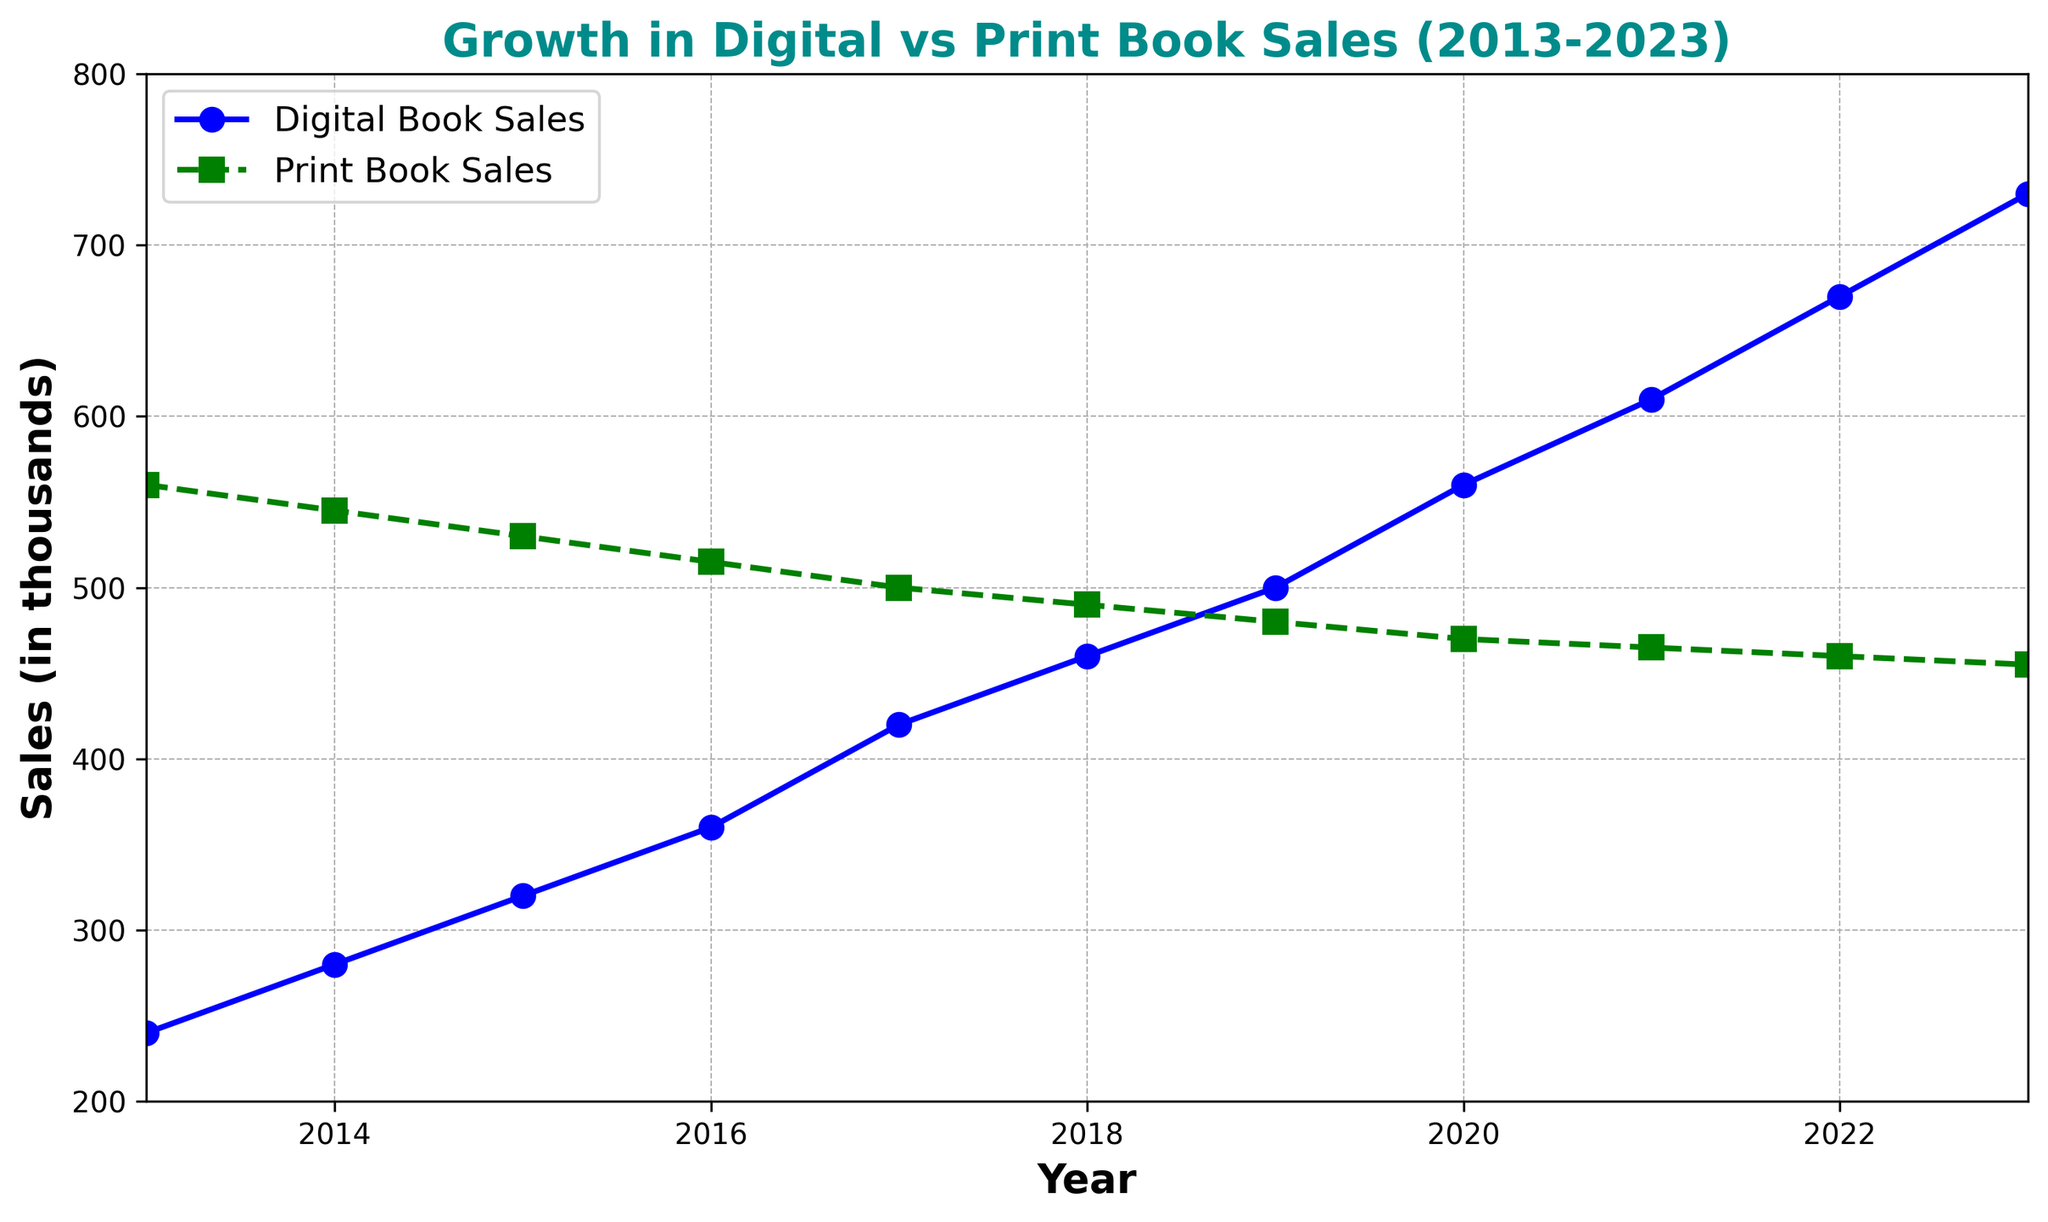Which year had the highest digital book sales? As we can see in the plot, 2023 had the highest point for digital book sales. This indicates that it had the highest digital book sales among all the years shown in the plot.
Answer: 2023 In what year did print book sales first drop below 500,000? By looking at the green dashed line representing print book sales, we see that it first dropped below 500,000 in 2018. Years 2017 and earlier are above 500,000.
Answer: 2018 How much has digital book sales increased from 2013 to 2023? The digital book sales in 2013 were 240,000, and in 2023, they were 730,000. Subtracting the former from the latter gives us the total increase: 730,000 - 240,000.
Answer: 490,000 Which year shows the largest gap between digital and print book sales? We need to compare the differences between blue and green lines for each year. The largest gap appears in 2023, where digital book sales are significantly higher than print book sales.
Answer: 2023 During which years did digital book sales exceed print book sales? From the plot, digital book sales exceed print book sales during 2020, 2021, 2022, and 2023.
Answer: 2020, 2021, 2022, 2023 What is the average print book sales from 2013 to 2023? The print book sales values from 2013 to 2023 are: 560, 545, 530, 515, 500, 490, 480, 470, 465, 460, 455. Summing these and dividing by 11 gives us the average: (560 + 545 + 530 + 515 + 500 + 490 + 480 + 470 + 465 + 460 + 455) / 11.
Answer: 495,000 What was the trend in digital book sales between 2015 and 2020? The blue line for digital book sales shows a steady rise from 2015 (320,000) to 2020 (560,000), indicating a consistent growth trend.
Answer: Steady rise Which type of book sales showed a consistent decline over the years? The green dashed line representing print book sales shows a consistent decline from 2013 to 2023.
Answer: Print book sales By how much did the digital book sales grow annually on average from 2018 to 2023? The digital book sales in 2018 were 460,000, and in 2023, they were 730,000. The difference between these years is 730,000 - 460,000 = 270,000. Dividing this by the number of years (2023 - 2018 = 5) gives the average annual growth: 270,000 / 5.
Answer: 54,000 Between which consecutive years was the smallest increase in digital book sales? Checking the blue line increments year-by-year reveals that the smallest increase was between 2021 (610,000) and 2022 (670,000), which is 670,000 - 610,000 = 60,000.
Answer: 2021-2022 